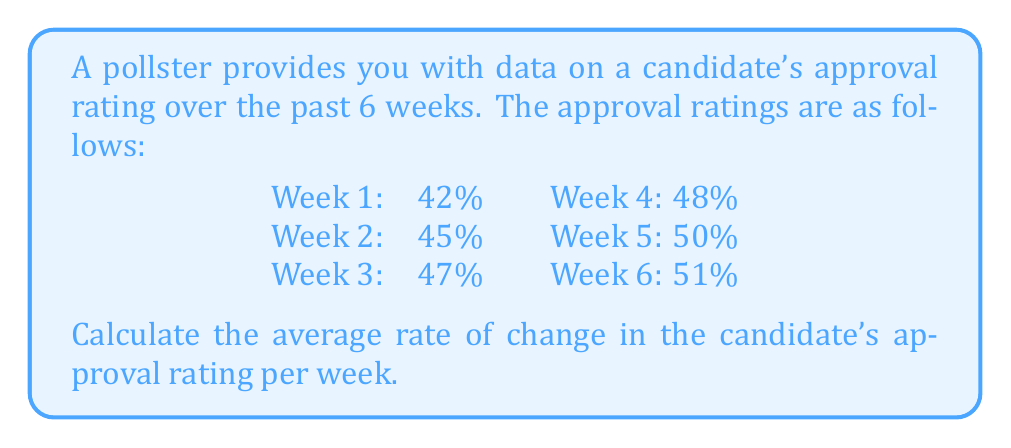Can you answer this question? To calculate the average rate of change in the candidate's approval rating per week, we need to follow these steps:

1. Determine the total change in approval rating:
   Final approval rating - Initial approval rating
   $51\% - 42\% = 9\%$

2. Determine the time period:
   6 weeks

3. Calculate the average rate of change using the formula:
   $$\text{Average rate of change} = \frac{\text{Total change}}{\text{Time period}}$$

   $$\text{Average rate of change} = \frac{9\%}{6 \text{ weeks}}$$

4. Simplify the fraction:
   $$\text{Average rate of change} = \frac{3\%}{2 \text{ weeks}} = 1.5\% \text{ per week}$$

Therefore, the average rate of change in the candidate's approval rating is 1.5% per week.
Answer: $1.5\%$ per week 